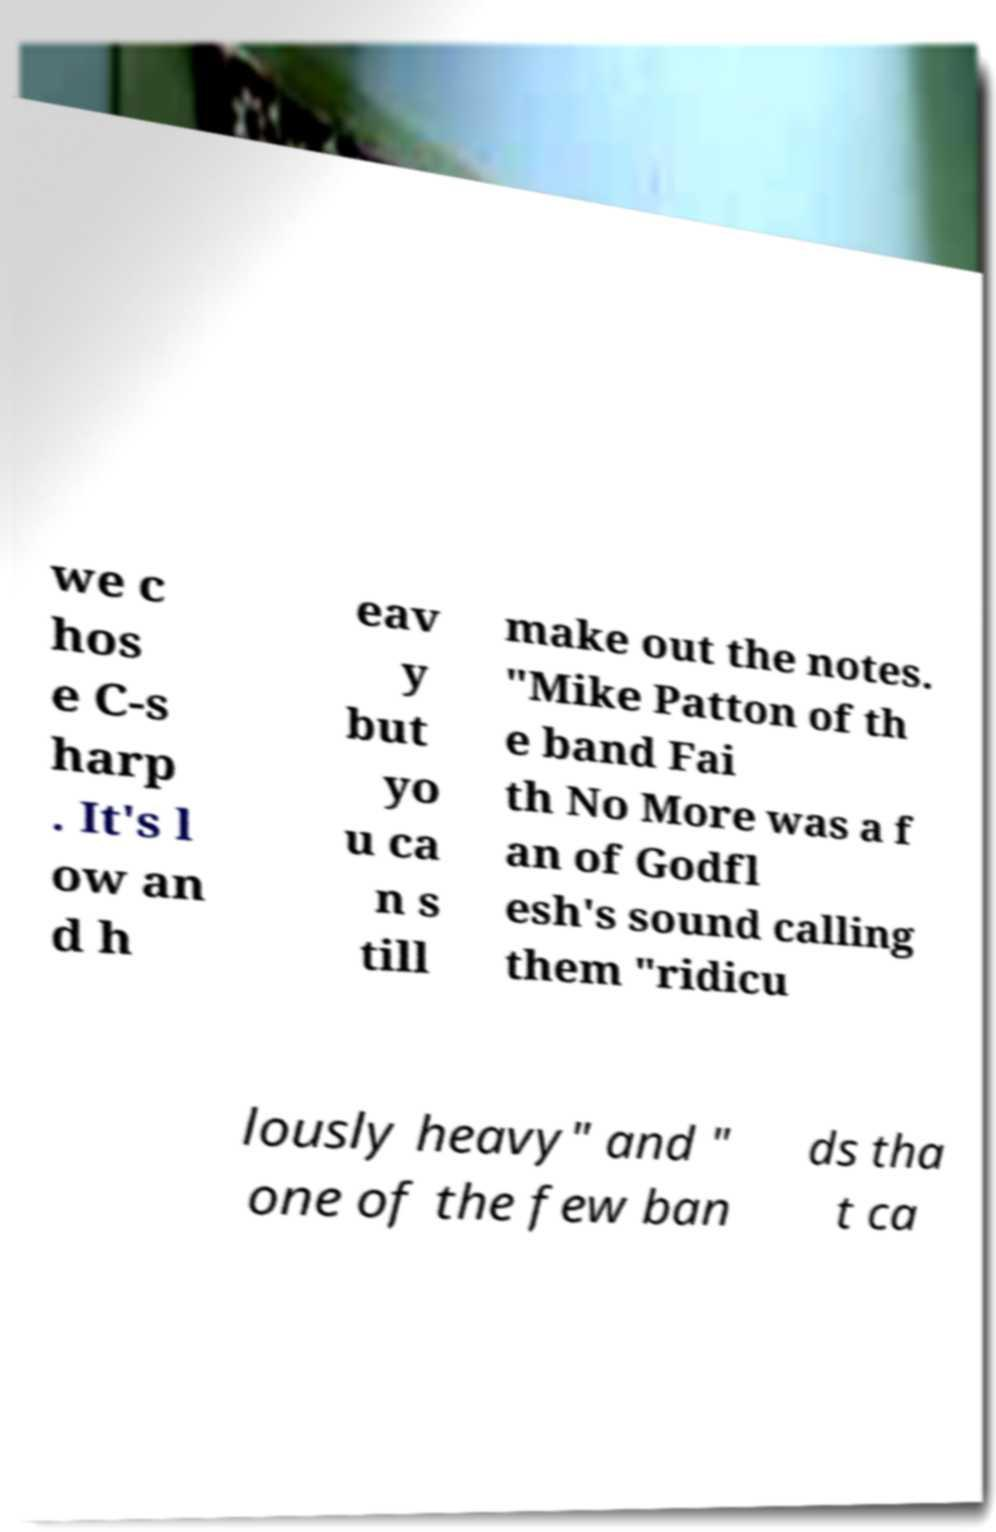Could you extract and type out the text from this image? we c hos e C-s harp . It's l ow an d h eav y but yo u ca n s till make out the notes. "Mike Patton of th e band Fai th No More was a f an of Godfl esh's sound calling them "ridicu lously heavy" and " one of the few ban ds tha t ca 